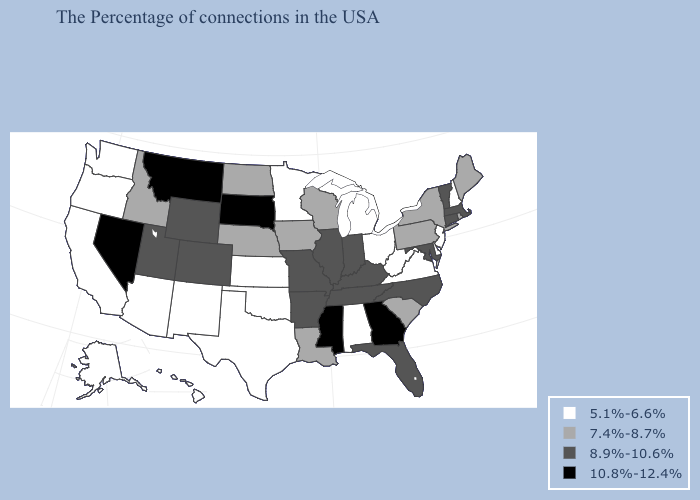What is the value of Utah?
Quick response, please. 8.9%-10.6%. Name the states that have a value in the range 8.9%-10.6%?
Concise answer only. Massachusetts, Vermont, Connecticut, Maryland, North Carolina, Florida, Kentucky, Indiana, Tennessee, Illinois, Missouri, Arkansas, Wyoming, Colorado, Utah. Which states have the highest value in the USA?
Keep it brief. Georgia, Mississippi, South Dakota, Montana, Nevada. Among the states that border Nevada , does Arizona have the highest value?
Give a very brief answer. No. What is the lowest value in states that border Alabama?
Keep it brief. 8.9%-10.6%. Name the states that have a value in the range 5.1%-6.6%?
Quick response, please. New Hampshire, New Jersey, Delaware, Virginia, West Virginia, Ohio, Michigan, Alabama, Minnesota, Kansas, Oklahoma, Texas, New Mexico, Arizona, California, Washington, Oregon, Alaska, Hawaii. Which states have the highest value in the USA?
Answer briefly. Georgia, Mississippi, South Dakota, Montana, Nevada. What is the value of Nebraska?
Quick response, please. 7.4%-8.7%. Does Texas have a higher value than New Hampshire?
Quick response, please. No. Name the states that have a value in the range 8.9%-10.6%?
Keep it brief. Massachusetts, Vermont, Connecticut, Maryland, North Carolina, Florida, Kentucky, Indiana, Tennessee, Illinois, Missouri, Arkansas, Wyoming, Colorado, Utah. What is the value of Illinois?
Write a very short answer. 8.9%-10.6%. Name the states that have a value in the range 7.4%-8.7%?
Give a very brief answer. Maine, Rhode Island, New York, Pennsylvania, South Carolina, Wisconsin, Louisiana, Iowa, Nebraska, North Dakota, Idaho. Name the states that have a value in the range 5.1%-6.6%?
Give a very brief answer. New Hampshire, New Jersey, Delaware, Virginia, West Virginia, Ohio, Michigan, Alabama, Minnesota, Kansas, Oklahoma, Texas, New Mexico, Arizona, California, Washington, Oregon, Alaska, Hawaii. Name the states that have a value in the range 7.4%-8.7%?
Give a very brief answer. Maine, Rhode Island, New York, Pennsylvania, South Carolina, Wisconsin, Louisiana, Iowa, Nebraska, North Dakota, Idaho. Does Montana have the highest value in the West?
Answer briefly. Yes. 